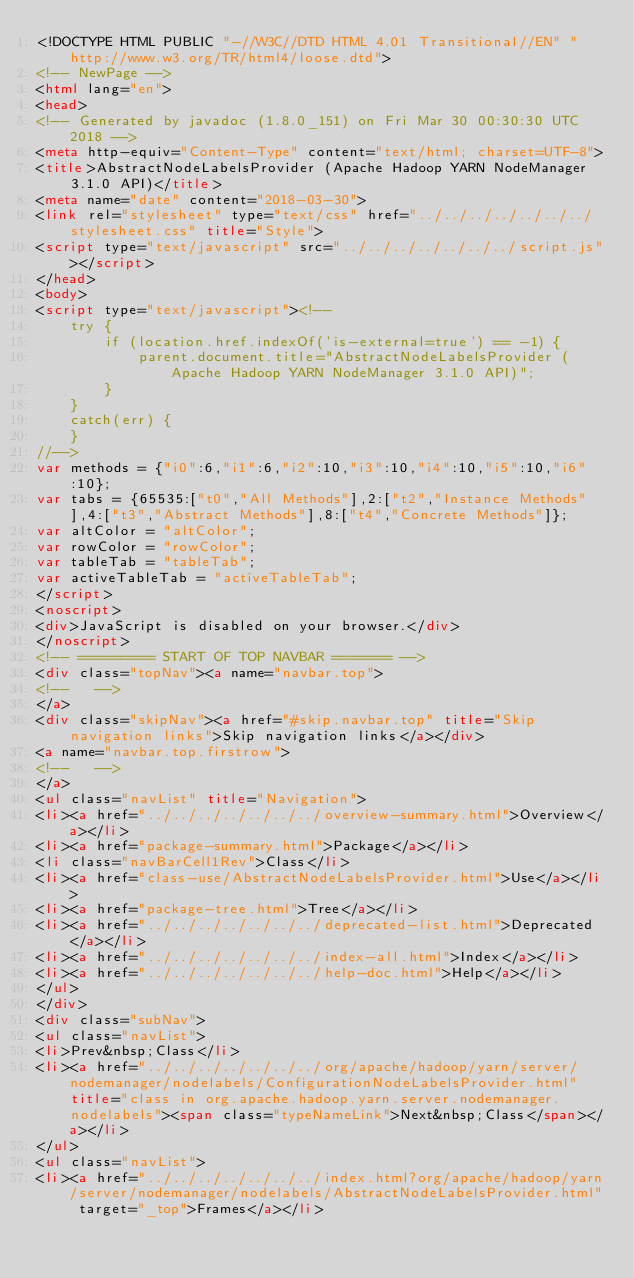Convert code to text. <code><loc_0><loc_0><loc_500><loc_500><_HTML_><!DOCTYPE HTML PUBLIC "-//W3C//DTD HTML 4.01 Transitional//EN" "http://www.w3.org/TR/html4/loose.dtd">
<!-- NewPage -->
<html lang="en">
<head>
<!-- Generated by javadoc (1.8.0_151) on Fri Mar 30 00:30:30 UTC 2018 -->
<meta http-equiv="Content-Type" content="text/html; charset=UTF-8">
<title>AbstractNodeLabelsProvider (Apache Hadoop YARN NodeManager 3.1.0 API)</title>
<meta name="date" content="2018-03-30">
<link rel="stylesheet" type="text/css" href="../../../../../../../stylesheet.css" title="Style">
<script type="text/javascript" src="../../../../../../../script.js"></script>
</head>
<body>
<script type="text/javascript"><!--
    try {
        if (location.href.indexOf('is-external=true') == -1) {
            parent.document.title="AbstractNodeLabelsProvider (Apache Hadoop YARN NodeManager 3.1.0 API)";
        }
    }
    catch(err) {
    }
//-->
var methods = {"i0":6,"i1":6,"i2":10,"i3":10,"i4":10,"i5":10,"i6":10};
var tabs = {65535:["t0","All Methods"],2:["t2","Instance Methods"],4:["t3","Abstract Methods"],8:["t4","Concrete Methods"]};
var altColor = "altColor";
var rowColor = "rowColor";
var tableTab = "tableTab";
var activeTableTab = "activeTableTab";
</script>
<noscript>
<div>JavaScript is disabled on your browser.</div>
</noscript>
<!-- ========= START OF TOP NAVBAR ======= -->
<div class="topNav"><a name="navbar.top">
<!--   -->
</a>
<div class="skipNav"><a href="#skip.navbar.top" title="Skip navigation links">Skip navigation links</a></div>
<a name="navbar.top.firstrow">
<!--   -->
</a>
<ul class="navList" title="Navigation">
<li><a href="../../../../../../../overview-summary.html">Overview</a></li>
<li><a href="package-summary.html">Package</a></li>
<li class="navBarCell1Rev">Class</li>
<li><a href="class-use/AbstractNodeLabelsProvider.html">Use</a></li>
<li><a href="package-tree.html">Tree</a></li>
<li><a href="../../../../../../../deprecated-list.html">Deprecated</a></li>
<li><a href="../../../../../../../index-all.html">Index</a></li>
<li><a href="../../../../../../../help-doc.html">Help</a></li>
</ul>
</div>
<div class="subNav">
<ul class="navList">
<li>Prev&nbsp;Class</li>
<li><a href="../../../../../../../org/apache/hadoop/yarn/server/nodemanager/nodelabels/ConfigurationNodeLabelsProvider.html" title="class in org.apache.hadoop.yarn.server.nodemanager.nodelabels"><span class="typeNameLink">Next&nbsp;Class</span></a></li>
</ul>
<ul class="navList">
<li><a href="../../../../../../../index.html?org/apache/hadoop/yarn/server/nodemanager/nodelabels/AbstractNodeLabelsProvider.html" target="_top">Frames</a></li></code> 